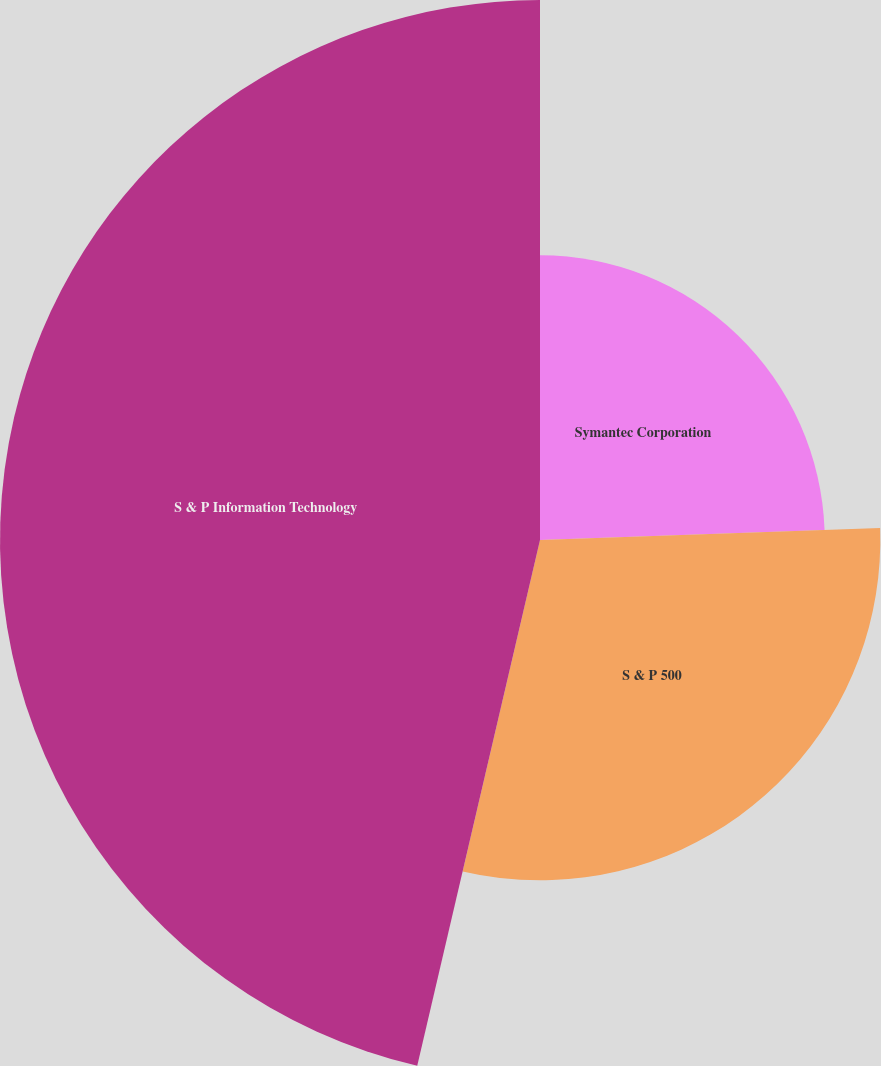Convert chart to OTSL. <chart><loc_0><loc_0><loc_500><loc_500><pie_chart><fcel>Symantec Corporation<fcel>S & P 500<fcel>S & P Information Technology<nl><fcel>24.44%<fcel>29.21%<fcel>46.35%<nl></chart> 